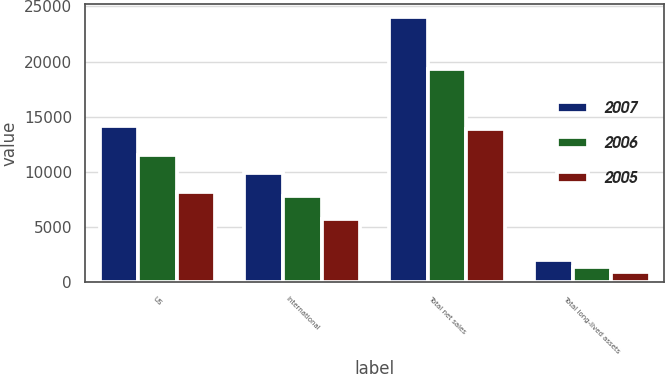Convert chart. <chart><loc_0><loc_0><loc_500><loc_500><stacked_bar_chart><ecel><fcel>US<fcel>International<fcel>Total net sales<fcel>Total long-lived assets<nl><fcel>2007<fcel>14128<fcel>9878<fcel>24006<fcel>2012<nl><fcel>2006<fcel>11486<fcel>7829<fcel>19315<fcel>1368<nl><fcel>2005<fcel>8194<fcel>5737<fcel>13931<fcel>913<nl></chart> 